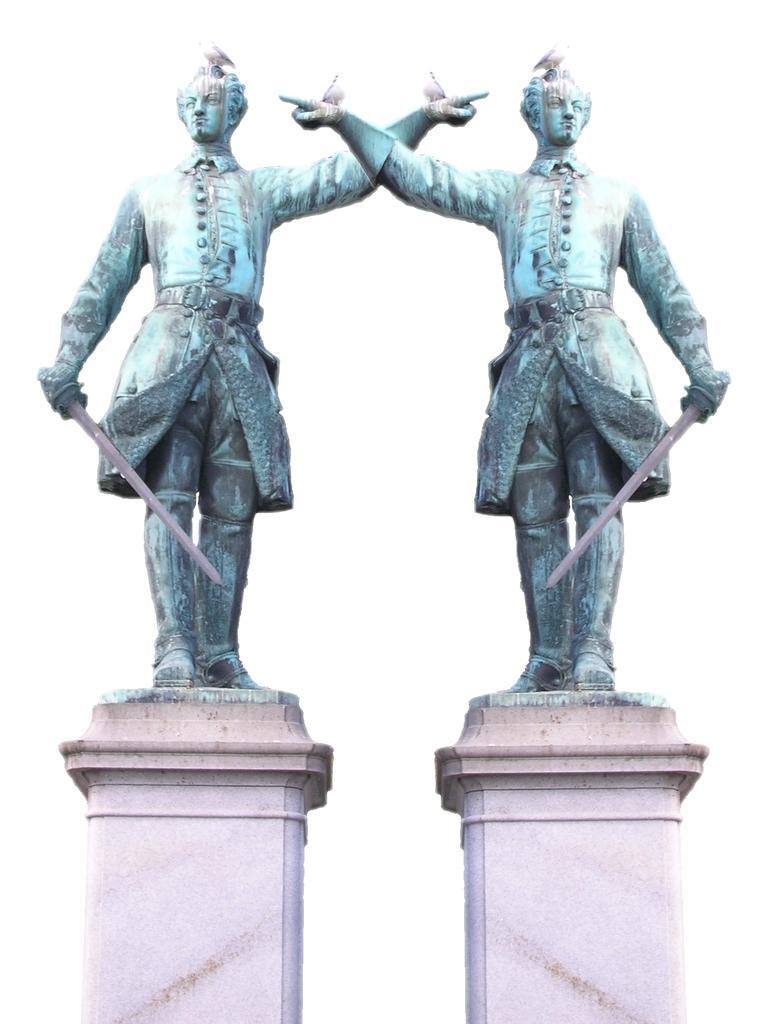Please provide a concise description of this image. In this image we can see two statues with some birds placed on the concrete stands. 